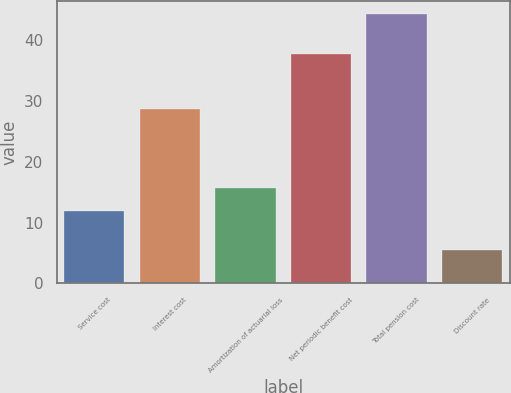<chart> <loc_0><loc_0><loc_500><loc_500><bar_chart><fcel>Service cost<fcel>Interest cost<fcel>Amortization of actuarial loss<fcel>Net periodic benefit cost<fcel>Total pension cost<fcel>Discount rate<nl><fcel>11.9<fcel>28.7<fcel>15.78<fcel>37.8<fcel>44.3<fcel>5.5<nl></chart> 